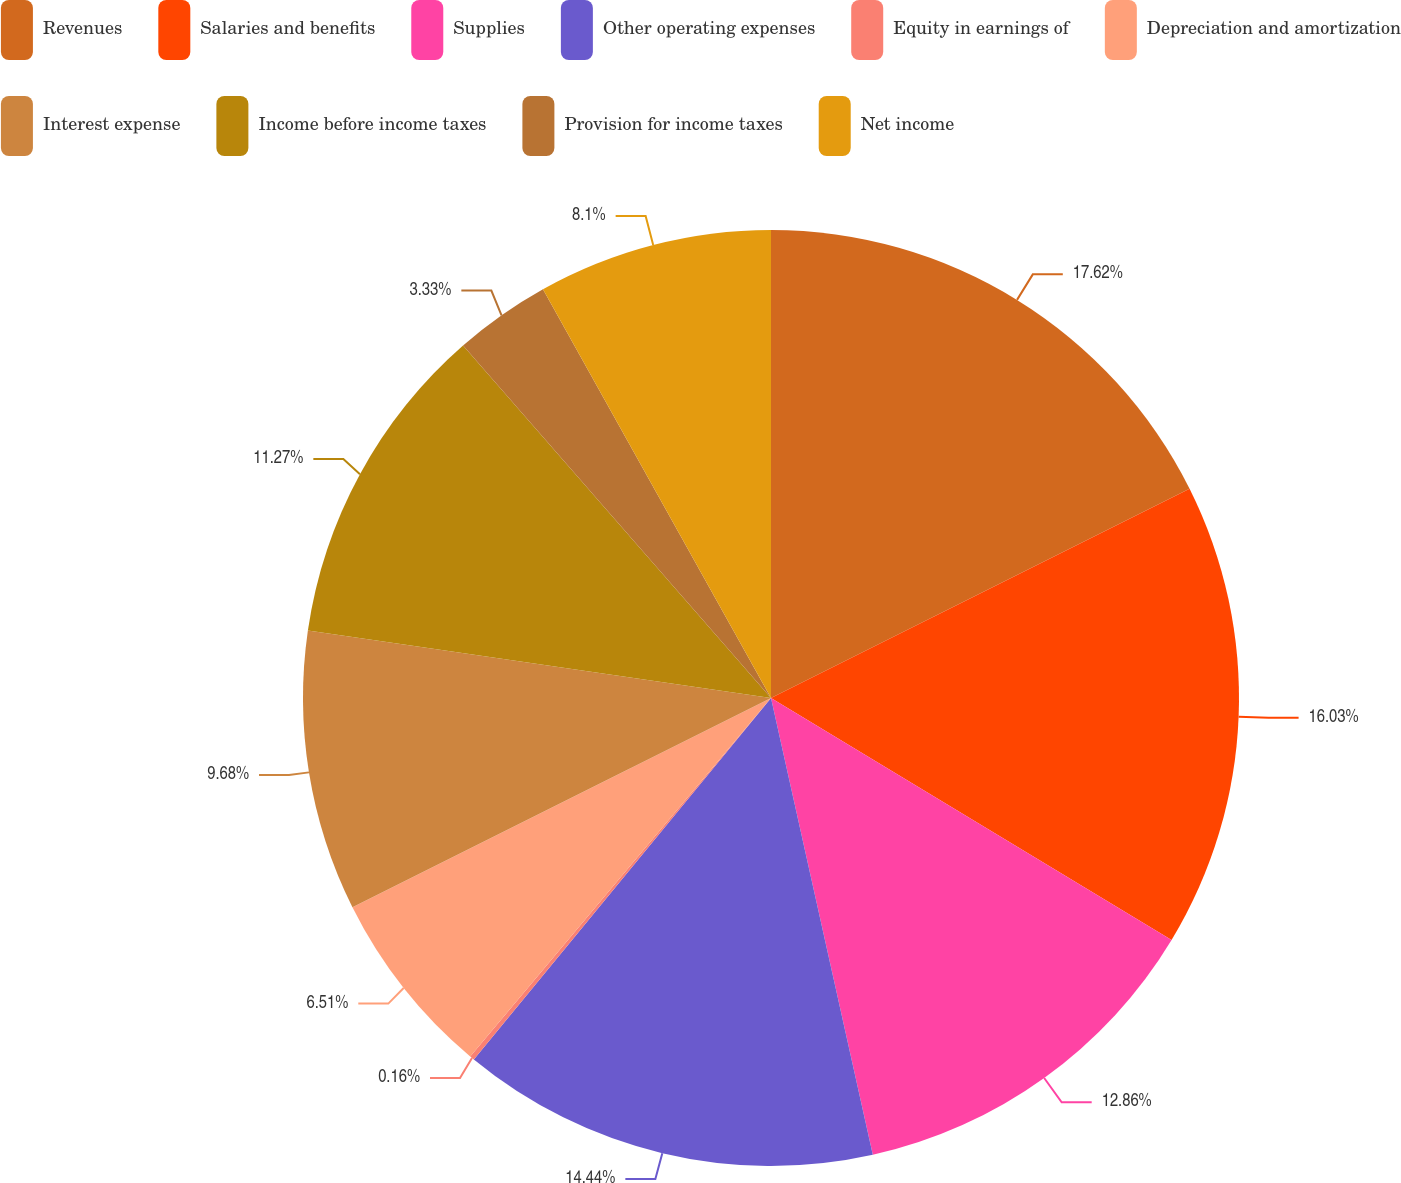Convert chart. <chart><loc_0><loc_0><loc_500><loc_500><pie_chart><fcel>Revenues<fcel>Salaries and benefits<fcel>Supplies<fcel>Other operating expenses<fcel>Equity in earnings of<fcel>Depreciation and amortization<fcel>Interest expense<fcel>Income before income taxes<fcel>Provision for income taxes<fcel>Net income<nl><fcel>17.62%<fcel>16.03%<fcel>12.86%<fcel>14.44%<fcel>0.16%<fcel>6.51%<fcel>9.68%<fcel>11.27%<fcel>3.33%<fcel>8.1%<nl></chart> 